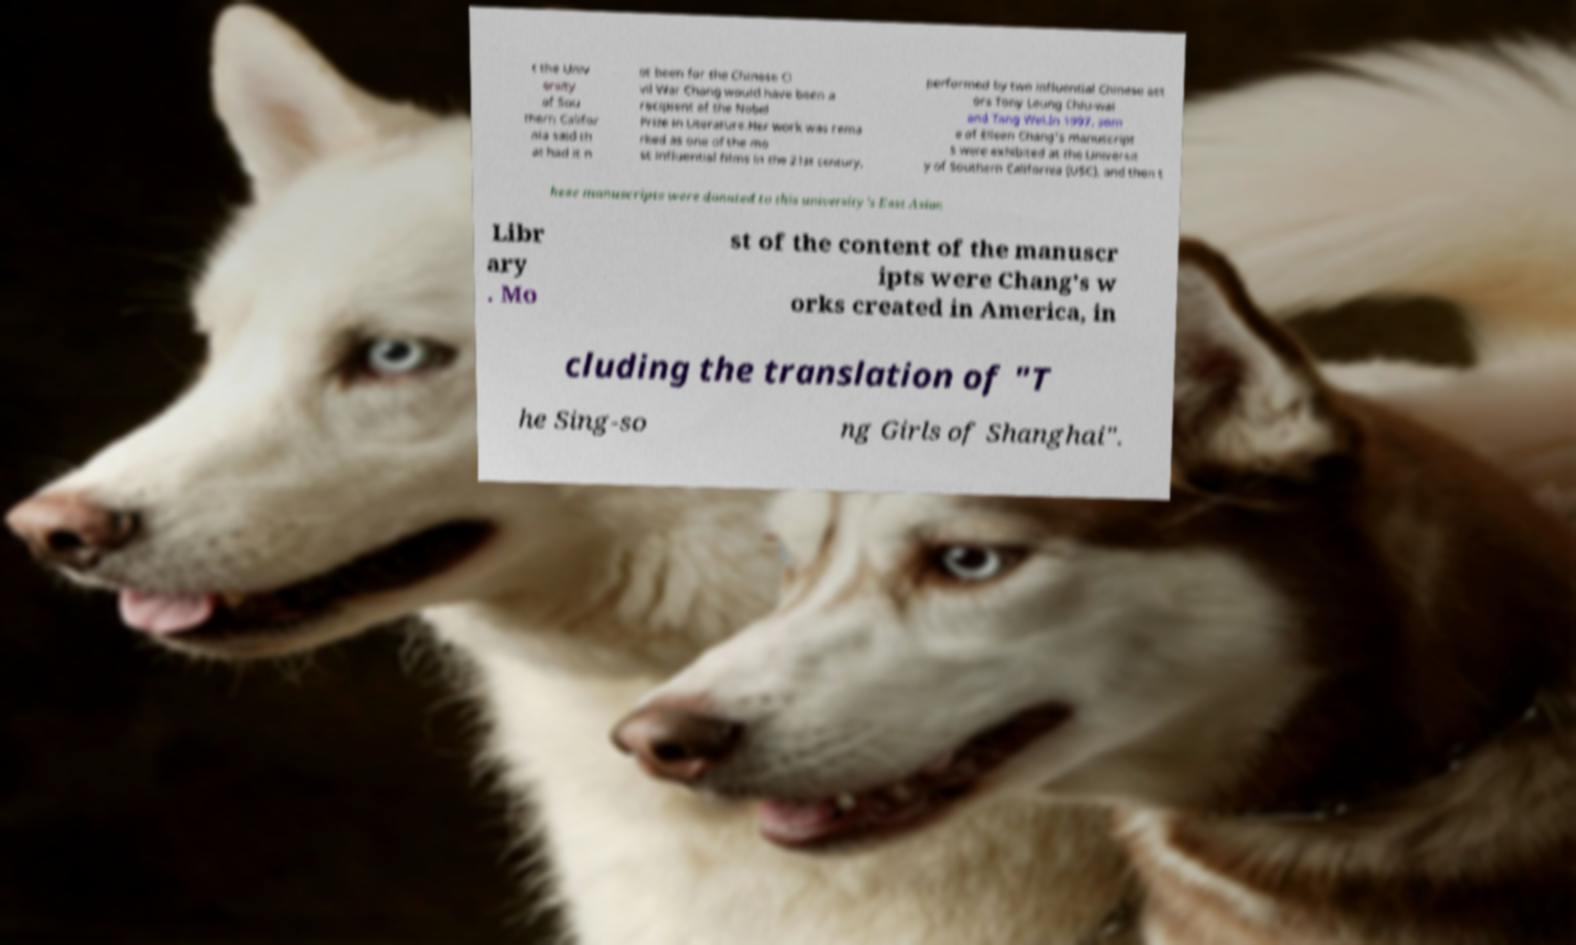Please read and relay the text visible in this image. What does it say? t the Univ ersity of Sou thern Califor nia said th at had it n ot been for the Chinese Ci vil War Chang would have been a recipient of the Nobel Prize in Literature.Her work was rema rked as one of the mo st influential films in the 21st century, performed by two influential Chinese act ors Tony Leung Chiu-wai and Tang Wei.In 1997, som e of Eileen Chang's manuscript s were exhibited at the Universit y of Southern California (USC), and then t hese manuscripts were donated to this university's East Asian Libr ary . Mo st of the content of the manuscr ipts were Chang's w orks created in America, in cluding the translation of "T he Sing-so ng Girls of Shanghai". 